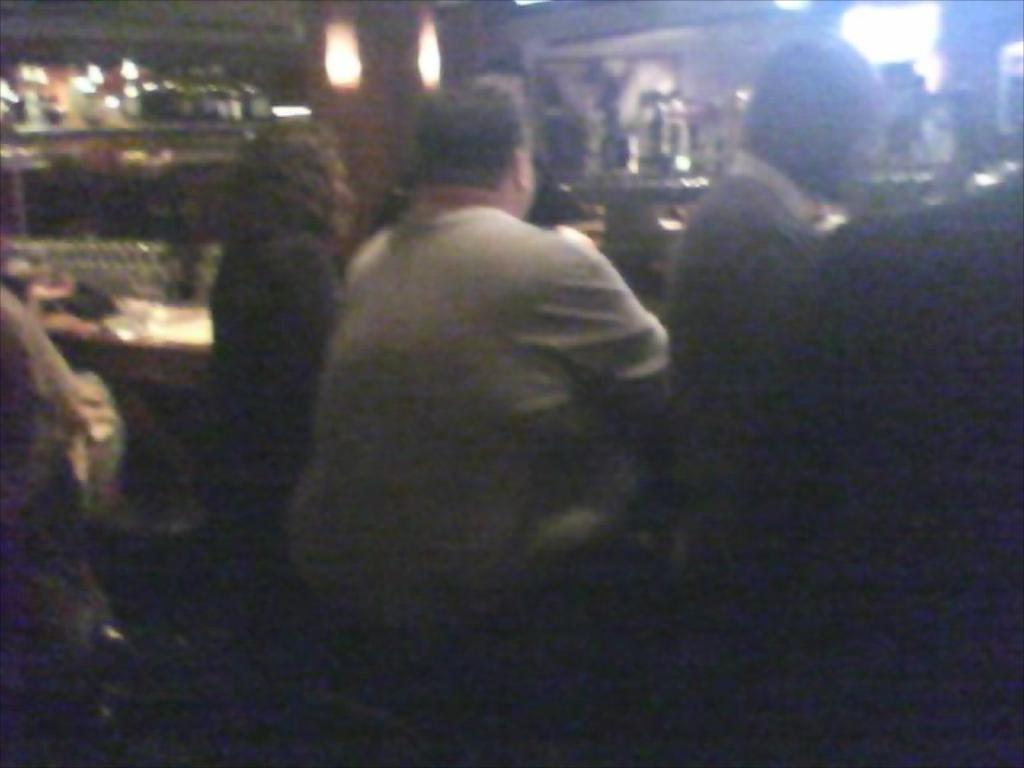In one or two sentences, can you explain what this image depicts? This picture is blur, in this picture we can see people and objects. 